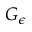<formula> <loc_0><loc_0><loc_500><loc_500>G _ { \epsilon }</formula> 